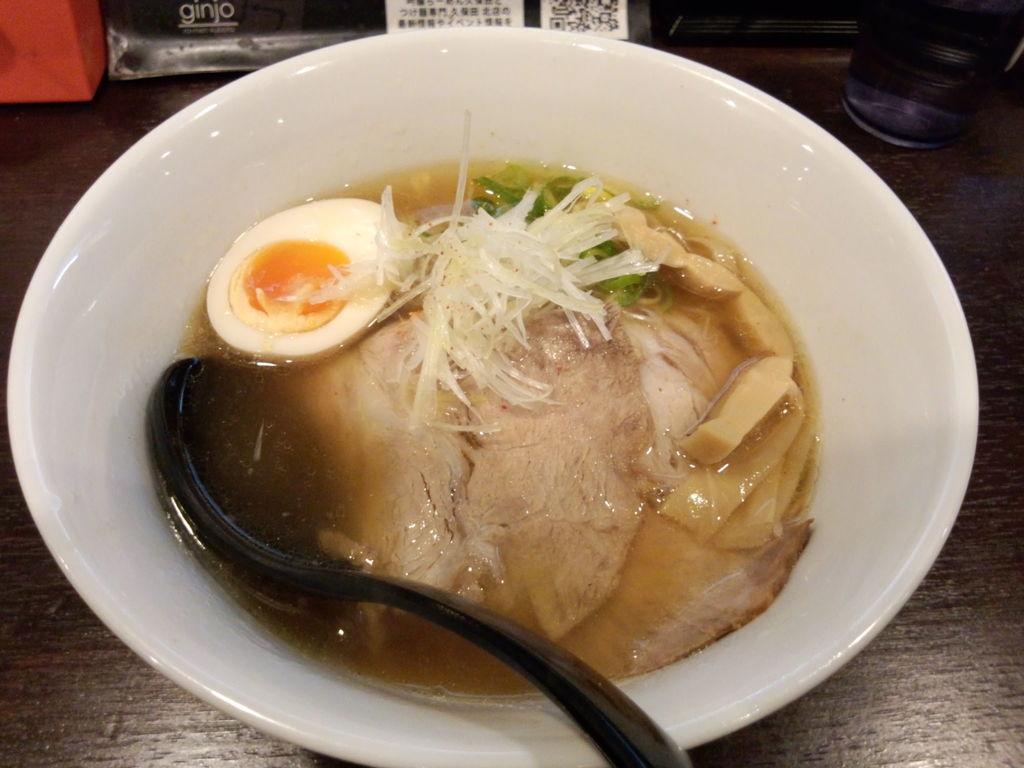In one or two sentences, can you explain what this image depicts? This is a bowl, which contains soup, meat, boiled egg and few other ingredients added to it. This looks like a serving spoon. I can see a bowl, glass and few other objects placed on the wooden table. 